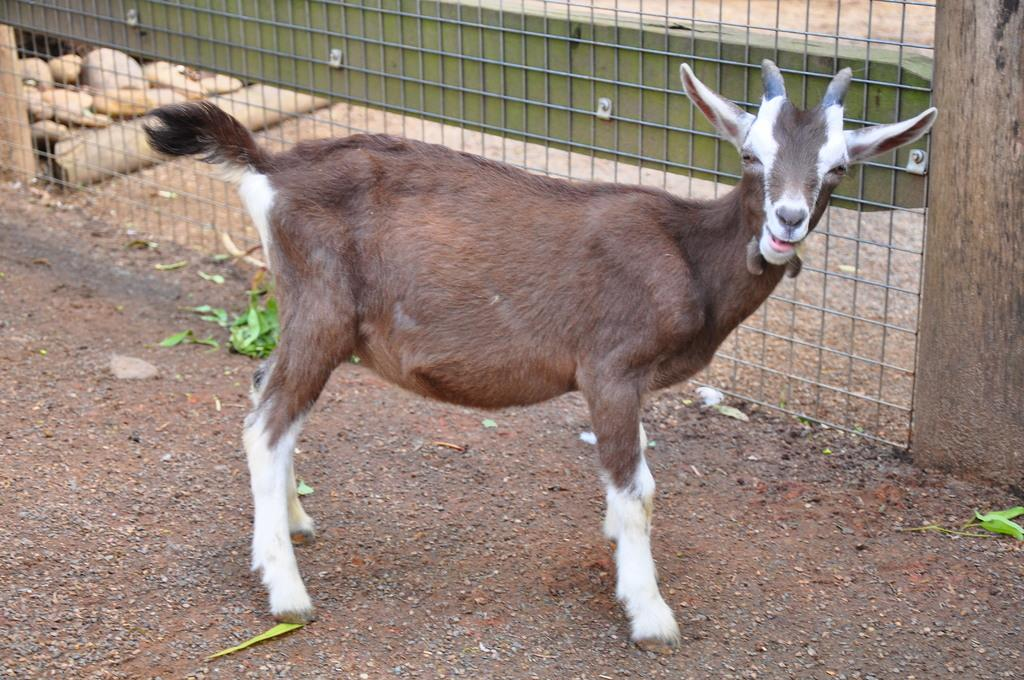What type of animal is present in the image? There is a goat in the image. What type of barrier is visible in the image? There is an iron fence in the image. What type of natural material is present in the image? There are stones in the image. What type of stamp can be seen on the goat's forehead in the image? There is no stamp present on the goat's forehead in the image. What type of earth is visible in the image? The image does not provide information about the type of earth present. 